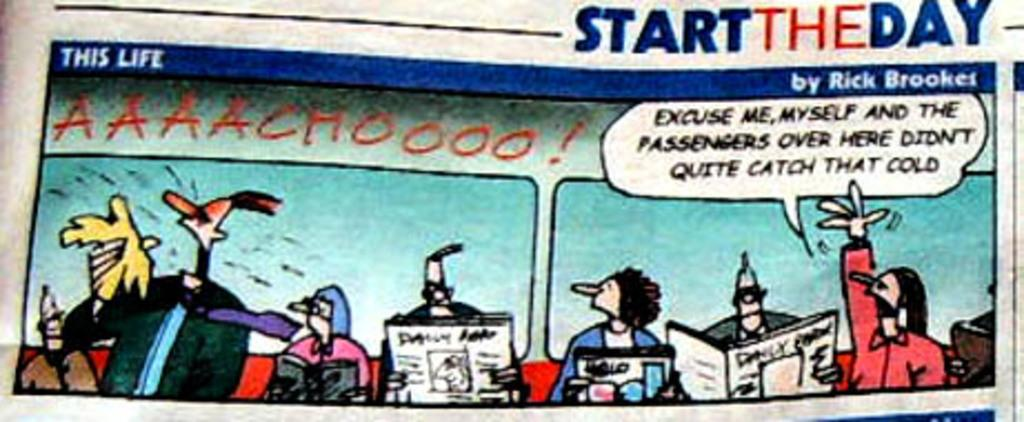<image>
Relay a brief, clear account of the picture shown. A comic called start the day is it talking about catching a cold. 